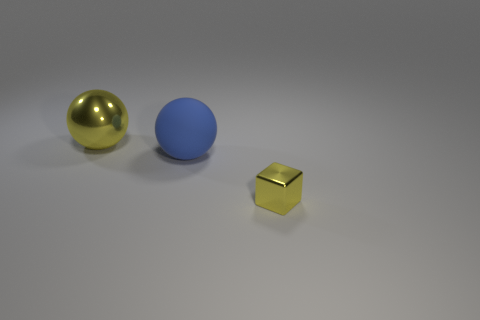Does the yellow shiny ball have the same size as the yellow cube?
Provide a short and direct response. No. What size is the ball that is right of the ball that is behind the large blue thing?
Provide a short and direct response. Large. Do the yellow thing behind the block and the large blue object have the same material?
Ensure brevity in your answer.  No. There is a yellow metallic thing on the right side of the big yellow sphere; what is its shape?
Your answer should be compact. Cube. What number of blue matte objects have the same size as the blue rubber ball?
Give a very brief answer. 0. The cube has what size?
Ensure brevity in your answer.  Small. There is a metallic block; what number of metal things are in front of it?
Offer a very short reply. 0. What shape is the yellow object that is made of the same material as the big yellow sphere?
Provide a short and direct response. Cube. Are there fewer tiny yellow blocks that are right of the metallic cube than metal balls behind the matte ball?
Offer a terse response. Yes. Are there more big metallic balls than big green rubber balls?
Offer a very short reply. Yes. 